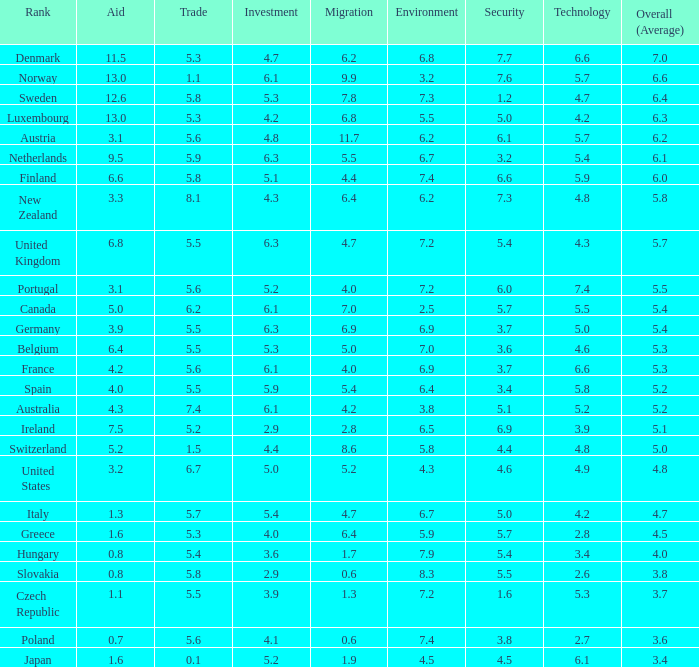What country has a 5.5 mark for security? Slovakia. Could you parse the entire table as a dict? {'header': ['Rank', 'Aid', 'Trade', 'Investment', 'Migration', 'Environment', 'Security', 'Technology', 'Overall (Average)'], 'rows': [['Denmark', '11.5', '5.3', '4.7', '6.2', '6.8', '7.7', '6.6', '7.0'], ['Norway', '13.0', '1.1', '6.1', '9.9', '3.2', '7.6', '5.7', '6.6'], ['Sweden', '12.6', '5.8', '5.3', '7.8', '7.3', '1.2', '4.7', '6.4'], ['Luxembourg', '13.0', '5.3', '4.2', '6.8', '5.5', '5.0', '4.2', '6.3'], ['Austria', '3.1', '5.6', '4.8', '11.7', '6.2', '6.1', '5.7', '6.2'], ['Netherlands', '9.5', '5.9', '6.3', '5.5', '6.7', '3.2', '5.4', '6.1'], ['Finland', '6.6', '5.8', '5.1', '4.4', '7.4', '6.6', '5.9', '6.0'], ['New Zealand', '3.3', '8.1', '4.3', '6.4', '6.2', '7.3', '4.8', '5.8'], ['United Kingdom', '6.8', '5.5', '6.3', '4.7', '7.2', '5.4', '4.3', '5.7'], ['Portugal', '3.1', '5.6', '5.2', '4.0', '7.2', '6.0', '7.4', '5.5'], ['Canada', '5.0', '6.2', '6.1', '7.0', '2.5', '5.7', '5.5', '5.4'], ['Germany', '3.9', '5.5', '6.3', '6.9', '6.9', '3.7', '5.0', '5.4'], ['Belgium', '6.4', '5.5', '5.3', '5.0', '7.0', '3.6', '4.6', '5.3'], ['France', '4.2', '5.6', '6.1', '4.0', '6.9', '3.7', '6.6', '5.3'], ['Spain', '4.0', '5.5', '5.9', '5.4', '6.4', '3.4', '5.8', '5.2'], ['Australia', '4.3', '7.4', '6.1', '4.2', '3.8', '5.1', '5.2', '5.2'], ['Ireland', '7.5', '5.2', '2.9', '2.8', '6.5', '6.9', '3.9', '5.1'], ['Switzerland', '5.2', '1.5', '4.4', '8.6', '5.8', '4.4', '4.8', '5.0'], ['United States', '3.2', '6.7', '5.0', '5.2', '4.3', '4.6', '4.9', '4.8'], ['Italy', '1.3', '5.7', '5.4', '4.7', '6.7', '5.0', '4.2', '4.7'], ['Greece', '1.6', '5.3', '4.0', '6.4', '5.9', '5.7', '2.8', '4.5'], ['Hungary', '0.8', '5.4', '3.6', '1.7', '7.9', '5.4', '3.4', '4.0'], ['Slovakia', '0.8', '5.8', '2.9', '0.6', '8.3', '5.5', '2.6', '3.8'], ['Czech Republic', '1.1', '5.5', '3.9', '1.3', '7.2', '1.6', '5.3', '3.7'], ['Poland', '0.7', '5.6', '4.1', '0.6', '7.4', '3.8', '2.7', '3.6'], ['Japan', '1.6', '0.1', '5.2', '1.9', '4.5', '4.5', '6.1', '3.4']]} 